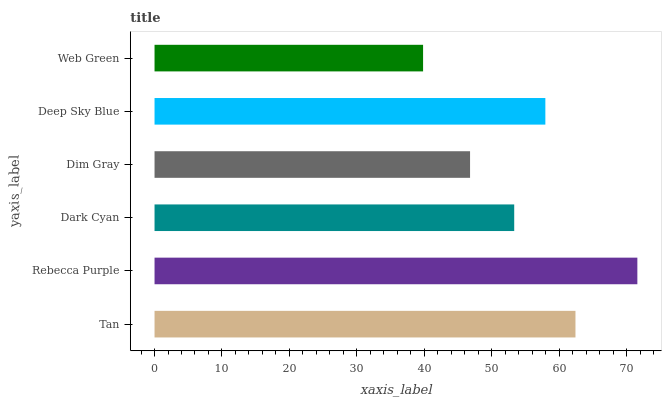Is Web Green the minimum?
Answer yes or no. Yes. Is Rebecca Purple the maximum?
Answer yes or no. Yes. Is Dark Cyan the minimum?
Answer yes or no. No. Is Dark Cyan the maximum?
Answer yes or no. No. Is Rebecca Purple greater than Dark Cyan?
Answer yes or no. Yes. Is Dark Cyan less than Rebecca Purple?
Answer yes or no. Yes. Is Dark Cyan greater than Rebecca Purple?
Answer yes or no. No. Is Rebecca Purple less than Dark Cyan?
Answer yes or no. No. Is Deep Sky Blue the high median?
Answer yes or no. Yes. Is Dark Cyan the low median?
Answer yes or no. Yes. Is Dim Gray the high median?
Answer yes or no. No. Is Rebecca Purple the low median?
Answer yes or no. No. 